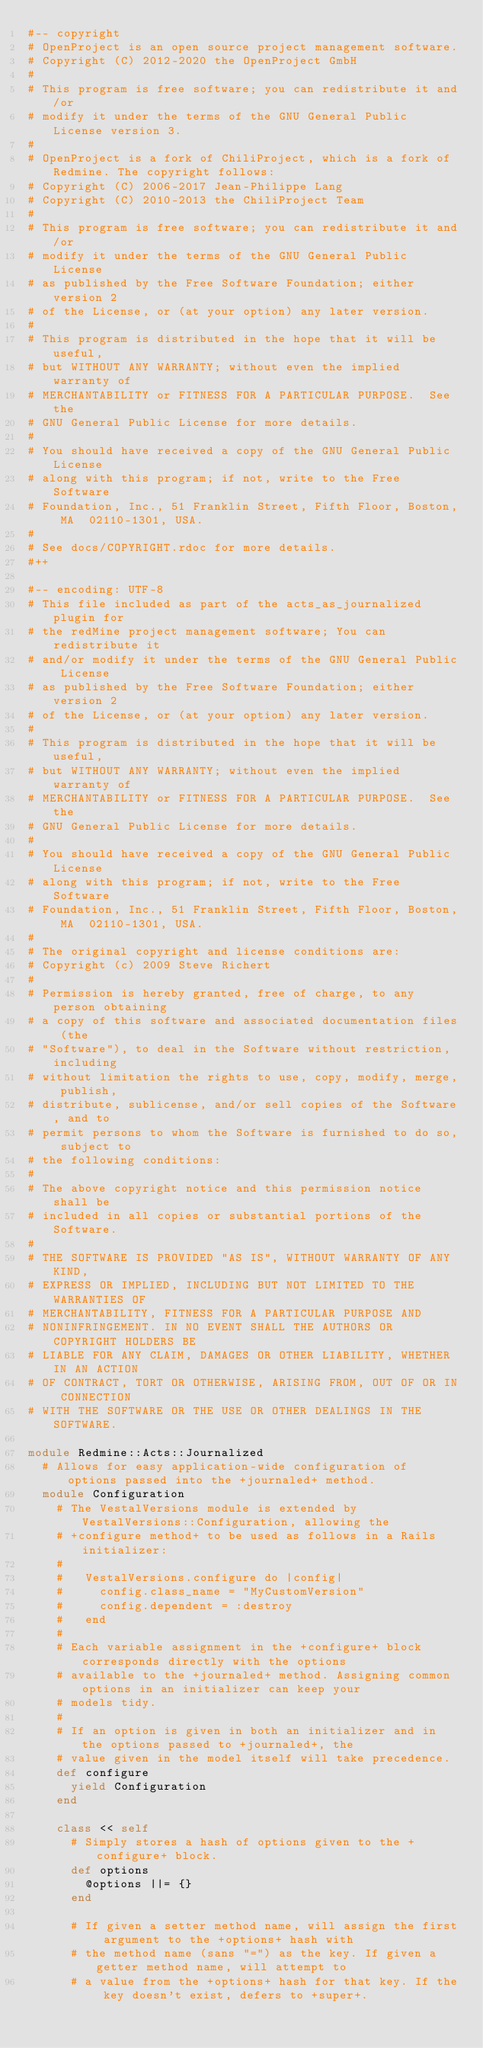Convert code to text. <code><loc_0><loc_0><loc_500><loc_500><_Ruby_>#-- copyright
# OpenProject is an open source project management software.
# Copyright (C) 2012-2020 the OpenProject GmbH
#
# This program is free software; you can redistribute it and/or
# modify it under the terms of the GNU General Public License version 3.
#
# OpenProject is a fork of ChiliProject, which is a fork of Redmine. The copyright follows:
# Copyright (C) 2006-2017 Jean-Philippe Lang
# Copyright (C) 2010-2013 the ChiliProject Team
#
# This program is free software; you can redistribute it and/or
# modify it under the terms of the GNU General Public License
# as published by the Free Software Foundation; either version 2
# of the License, or (at your option) any later version.
#
# This program is distributed in the hope that it will be useful,
# but WITHOUT ANY WARRANTY; without even the implied warranty of
# MERCHANTABILITY or FITNESS FOR A PARTICULAR PURPOSE.  See the
# GNU General Public License for more details.
#
# You should have received a copy of the GNU General Public License
# along with this program; if not, write to the Free Software
# Foundation, Inc., 51 Franklin Street, Fifth Floor, Boston, MA  02110-1301, USA.
#
# See docs/COPYRIGHT.rdoc for more details.
#++

#-- encoding: UTF-8
# This file included as part of the acts_as_journalized plugin for
# the redMine project management software; You can redistribute it
# and/or modify it under the terms of the GNU General Public License
# as published by the Free Software Foundation; either version 2
# of the License, or (at your option) any later version.
#
# This program is distributed in the hope that it will be useful,
# but WITHOUT ANY WARRANTY; without even the implied warranty of
# MERCHANTABILITY or FITNESS FOR A PARTICULAR PURPOSE.  See the
# GNU General Public License for more details.
#
# You should have received a copy of the GNU General Public License
# along with this program; if not, write to the Free Software
# Foundation, Inc., 51 Franklin Street, Fifth Floor, Boston, MA  02110-1301, USA.
#
# The original copyright and license conditions are:
# Copyright (c) 2009 Steve Richert
#
# Permission is hereby granted, free of charge, to any person obtaining
# a copy of this software and associated documentation files (the
# "Software"), to deal in the Software without restriction, including
# without limitation the rights to use, copy, modify, merge, publish,
# distribute, sublicense, and/or sell copies of the Software, and to
# permit persons to whom the Software is furnished to do so, subject to
# the following conditions:
#
# The above copyright notice and this permission notice shall be
# included in all copies or substantial portions of the Software.
#
# THE SOFTWARE IS PROVIDED "AS IS", WITHOUT WARRANTY OF ANY KIND,
# EXPRESS OR IMPLIED, INCLUDING BUT NOT LIMITED TO THE WARRANTIES OF
# MERCHANTABILITY, FITNESS FOR A PARTICULAR PURPOSE AND
# NONINFRINGEMENT. IN NO EVENT SHALL THE AUTHORS OR COPYRIGHT HOLDERS BE
# LIABLE FOR ANY CLAIM, DAMAGES OR OTHER LIABILITY, WHETHER IN AN ACTION
# OF CONTRACT, TORT OR OTHERWISE, ARISING FROM, OUT OF OR IN CONNECTION
# WITH THE SOFTWARE OR THE USE OR OTHER DEALINGS IN THE SOFTWARE.

module Redmine::Acts::Journalized
  # Allows for easy application-wide configuration of options passed into the +journaled+ method.
  module Configuration
    # The VestalVersions module is extended by VestalVersions::Configuration, allowing the
    # +configure method+ to be used as follows in a Rails initializer:
    #
    #   VestalVersions.configure do |config|
    #     config.class_name = "MyCustomVersion"
    #     config.dependent = :destroy
    #   end
    #
    # Each variable assignment in the +configure+ block corresponds directly with the options
    # available to the +journaled+ method. Assigning common options in an initializer can keep your
    # models tidy.
    #
    # If an option is given in both an initializer and in the options passed to +journaled+, the
    # value given in the model itself will take precedence.
    def configure
      yield Configuration
    end

    class << self
      # Simply stores a hash of options given to the +configure+ block.
      def options
        @options ||= {}
      end

      # If given a setter method name, will assign the first argument to the +options+ hash with
      # the method name (sans "=") as the key. If given a getter method name, will attempt to
      # a value from the +options+ hash for that key. If the key doesn't exist, defers to +super+.</code> 